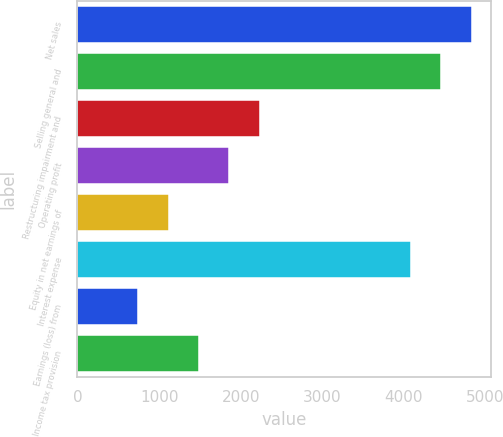<chart> <loc_0><loc_0><loc_500><loc_500><bar_chart><fcel>Net sales<fcel>Selling general and<fcel>Restructuring impairment and<fcel>Operating profit<fcel>Equity in net earnings of<fcel>Interest expense<fcel>Earnings (loss) from<fcel>Income tax provision<nl><fcel>4832.83<fcel>4461.22<fcel>2231.56<fcel>1859.95<fcel>1116.73<fcel>4089.61<fcel>745.12<fcel>1488.34<nl></chart> 